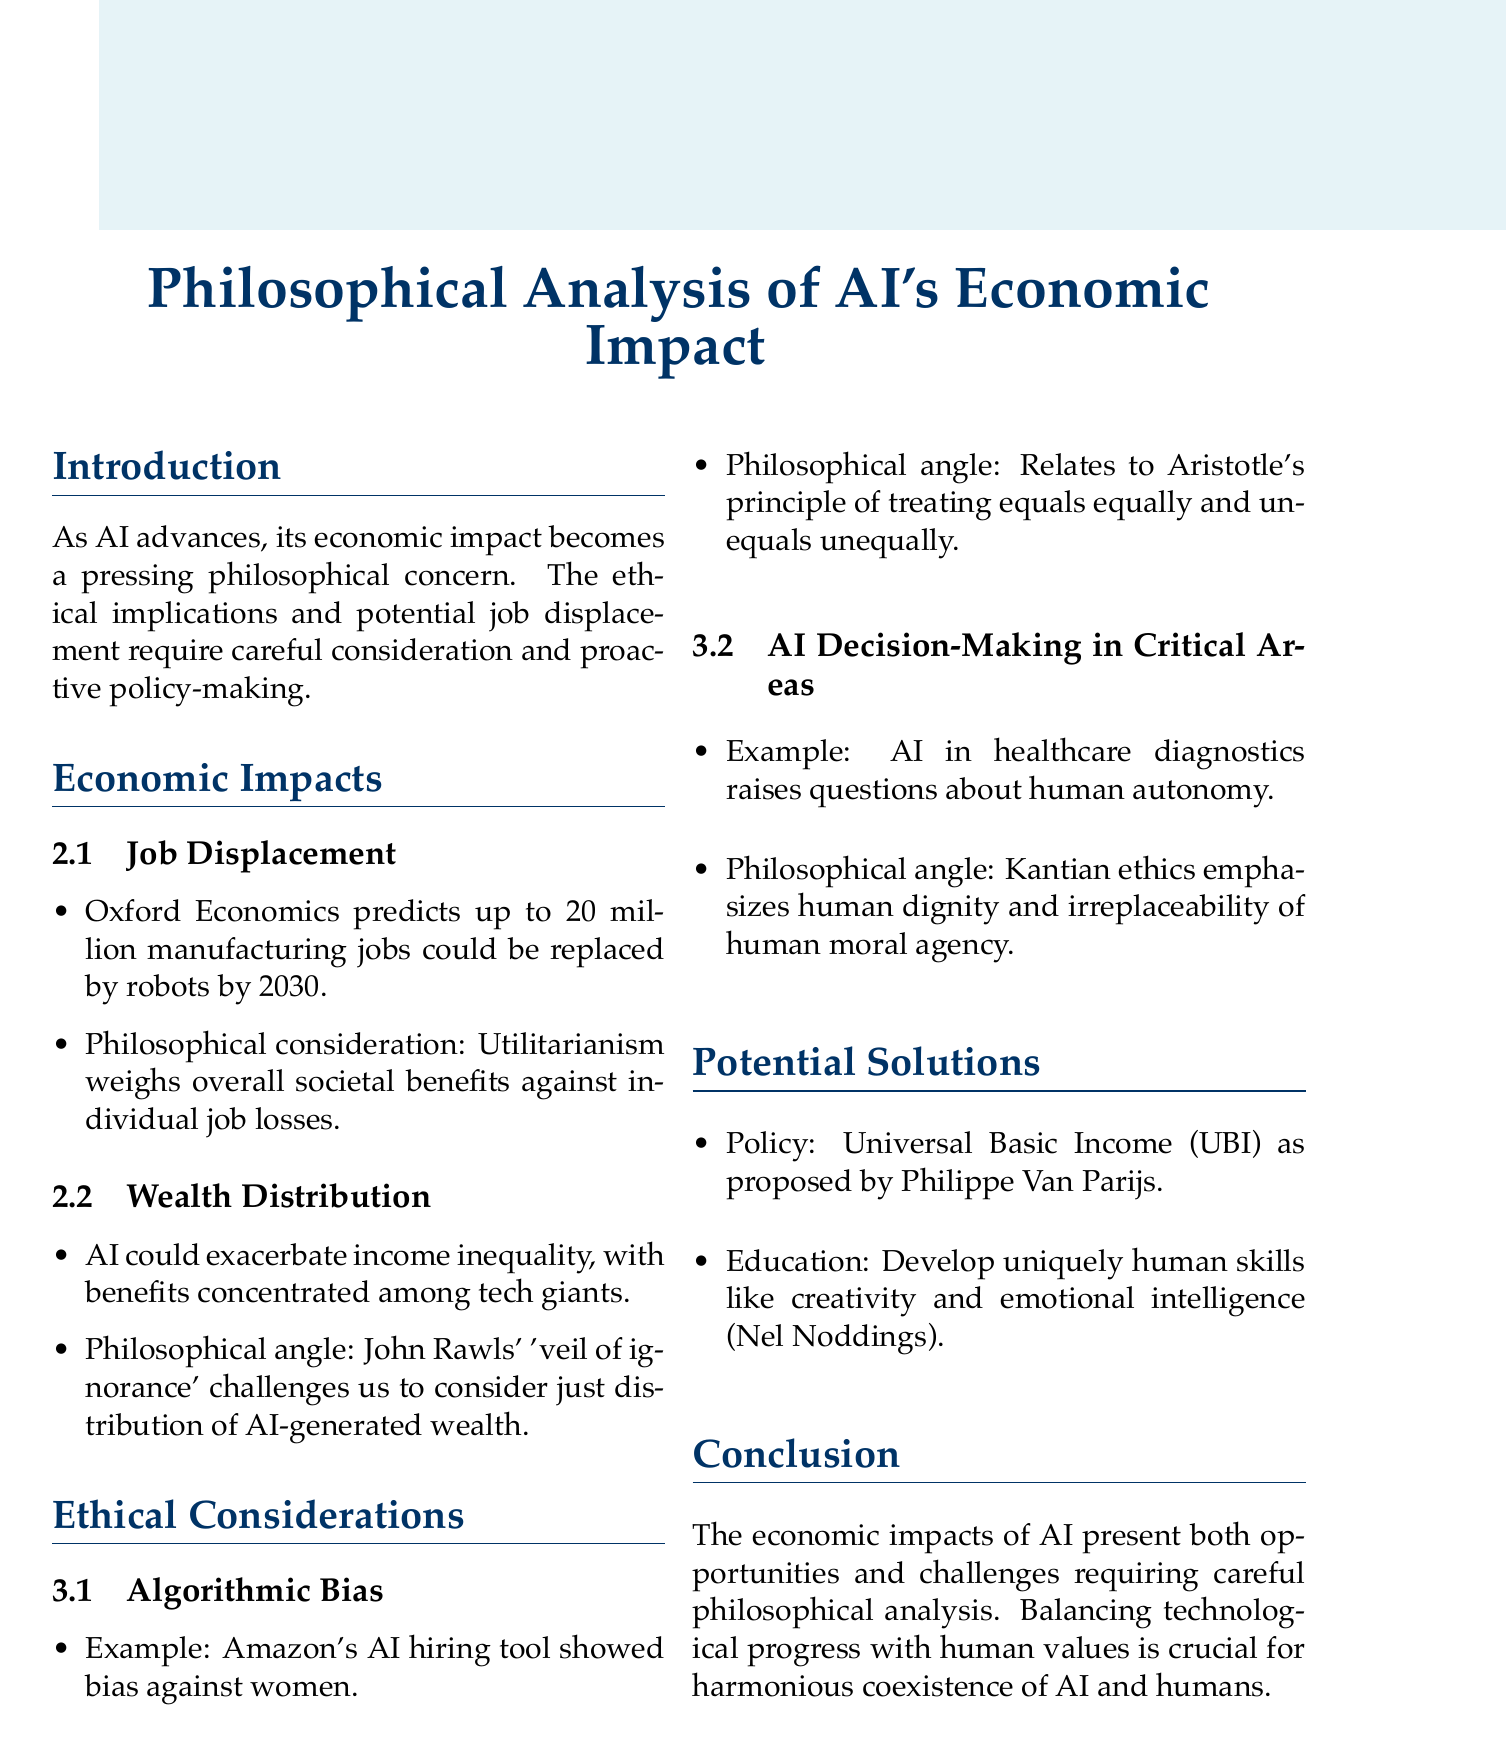What is the predicted number of manufacturing jobs that could be replaced by AI by 2030? The document cites Oxford Economics predicting that up to 20 million manufacturing jobs could be replaced by robots by 2030.
Answer: 20 million What ethical issue is raised by Amazon's AI hiring tool? The document states that Amazon's AI hiring tool showed bias against women, highlighting an ethical issue of algorithmic bias.
Answer: Algorithmic bias Which philosophical perspective is mentioned for job displacement considerations? The document indicates that a utilitarian perspective weighs the overall societal benefits of increased productivity against individual job losses.
Answer: Utilitarianism What is proposed as a potential solution to AI-induced unemployment? The document suggests Universal Basic Income (UBI) as a policy recommendation to address AI-induced unemployment.
Answer: Universal Basic Income Who is mentioned as advocating for the development of uniquely human skills? The document refers to educational philosopher Nel Noddings advocating for the emphasis on uniquely human skills like creativity and emotional intelligence.
Answer: Nel Noddings What principle does Aristotle's concept of fairness relate to in the context of AI? The document states that Aristotle's principle relates to treating equals equally and unequals unequally, addressing ethical concerns in AI development.
Answer: Equality What does Kantian ethics emphasize regarding AI decision-making? According to the document, Kantian ethics emphasizes human dignity and the irreplaceability of human moral agency in critical decision-making areas involving AI.
Answer: Human dignity What is the primary concern that AI's economic impact raises for society? The document highlights that the economic impact of AI raises pressing philosophical concerns, particularly for academia and the workforce.
Answer: Philosophical concerns 